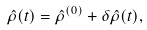Convert formula to latex. <formula><loc_0><loc_0><loc_500><loc_500>\hat { \rho } ( t ) = \hat { \rho } ^ { ( 0 ) } + \delta \hat { \rho } ( t ) ,</formula> 